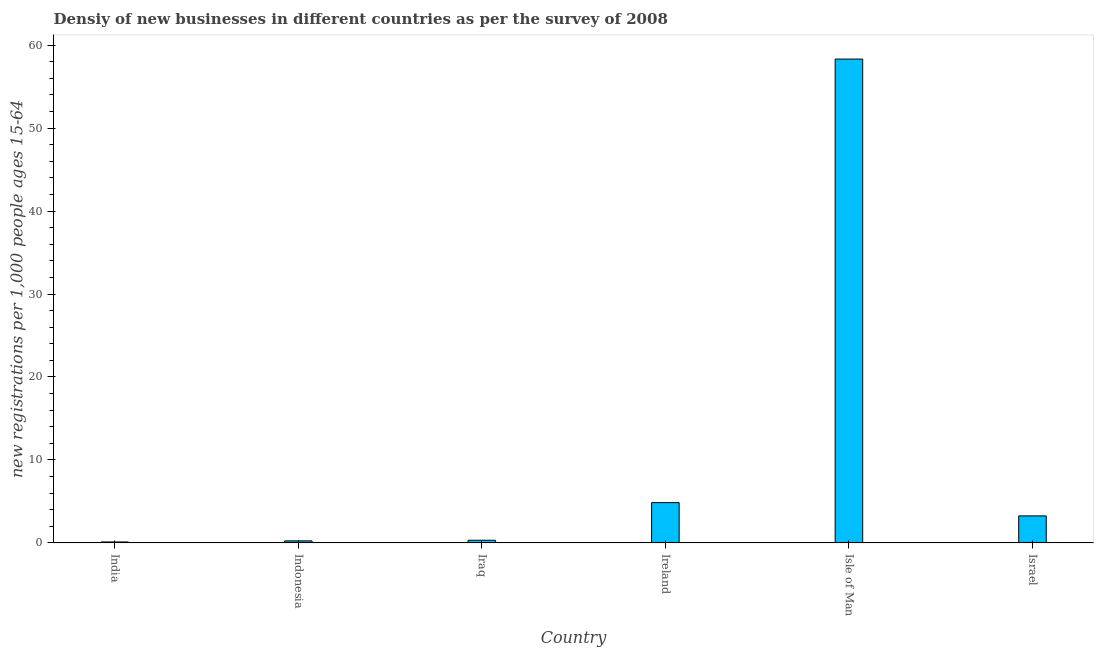Does the graph contain any zero values?
Offer a terse response. No. What is the title of the graph?
Give a very brief answer. Densiy of new businesses in different countries as per the survey of 2008. What is the label or title of the Y-axis?
Ensure brevity in your answer.  New registrations per 1,0 people ages 15-64. What is the density of new business in India?
Give a very brief answer. 0.11. Across all countries, what is the maximum density of new business?
Your answer should be very brief. 58.33. Across all countries, what is the minimum density of new business?
Your answer should be very brief. 0.11. In which country was the density of new business maximum?
Your response must be concise. Isle of Man. In which country was the density of new business minimum?
Provide a succinct answer. India. What is the sum of the density of new business?
Ensure brevity in your answer.  67.11. What is the difference between the density of new business in Indonesia and Isle of Man?
Your answer should be compact. -58.09. What is the average density of new business per country?
Keep it short and to the point. 11.19. What is the median density of new business?
Your answer should be very brief. 1.79. In how many countries, is the density of new business greater than 24 ?
Keep it short and to the point. 1. What is the difference between the highest and the second highest density of new business?
Keep it short and to the point. 53.48. What is the difference between the highest and the lowest density of new business?
Offer a terse response. 58.22. In how many countries, is the density of new business greater than the average density of new business taken over all countries?
Ensure brevity in your answer.  1. How many countries are there in the graph?
Your answer should be compact. 6. What is the difference between two consecutive major ticks on the Y-axis?
Offer a terse response. 10. Are the values on the major ticks of Y-axis written in scientific E-notation?
Give a very brief answer. No. What is the new registrations per 1,000 people ages 15-64 of India?
Offer a terse response. 0.11. What is the new registrations per 1,000 people ages 15-64 of Indonesia?
Your answer should be compact. 0.24. What is the new registrations per 1,000 people ages 15-64 in Iraq?
Offer a very short reply. 0.32. What is the new registrations per 1,000 people ages 15-64 in Ireland?
Provide a succinct answer. 4.85. What is the new registrations per 1,000 people ages 15-64 in Isle of Man?
Ensure brevity in your answer.  58.33. What is the new registrations per 1,000 people ages 15-64 in Israel?
Provide a succinct answer. 3.25. What is the difference between the new registrations per 1,000 people ages 15-64 in India and Indonesia?
Provide a short and direct response. -0.13. What is the difference between the new registrations per 1,000 people ages 15-64 in India and Iraq?
Offer a terse response. -0.2. What is the difference between the new registrations per 1,000 people ages 15-64 in India and Ireland?
Make the answer very short. -4.74. What is the difference between the new registrations per 1,000 people ages 15-64 in India and Isle of Man?
Offer a terse response. -58.22. What is the difference between the new registrations per 1,000 people ages 15-64 in India and Israel?
Give a very brief answer. -3.14. What is the difference between the new registrations per 1,000 people ages 15-64 in Indonesia and Iraq?
Offer a very short reply. -0.07. What is the difference between the new registrations per 1,000 people ages 15-64 in Indonesia and Ireland?
Offer a terse response. -4.61. What is the difference between the new registrations per 1,000 people ages 15-64 in Indonesia and Isle of Man?
Your answer should be compact. -58.09. What is the difference between the new registrations per 1,000 people ages 15-64 in Indonesia and Israel?
Your answer should be very brief. -3.01. What is the difference between the new registrations per 1,000 people ages 15-64 in Iraq and Ireland?
Offer a very short reply. -4.54. What is the difference between the new registrations per 1,000 people ages 15-64 in Iraq and Isle of Man?
Give a very brief answer. -58.01. What is the difference between the new registrations per 1,000 people ages 15-64 in Iraq and Israel?
Your response must be concise. -2.94. What is the difference between the new registrations per 1,000 people ages 15-64 in Ireland and Isle of Man?
Give a very brief answer. -53.48. What is the difference between the new registrations per 1,000 people ages 15-64 in Ireland and Israel?
Provide a short and direct response. 1.6. What is the difference between the new registrations per 1,000 people ages 15-64 in Isle of Man and Israel?
Your answer should be compact. 55.08. What is the ratio of the new registrations per 1,000 people ages 15-64 in India to that in Indonesia?
Your answer should be compact. 0.46. What is the ratio of the new registrations per 1,000 people ages 15-64 in India to that in Iraq?
Your response must be concise. 0.35. What is the ratio of the new registrations per 1,000 people ages 15-64 in India to that in Ireland?
Give a very brief answer. 0.02. What is the ratio of the new registrations per 1,000 people ages 15-64 in India to that in Isle of Man?
Give a very brief answer. 0. What is the ratio of the new registrations per 1,000 people ages 15-64 in India to that in Israel?
Your response must be concise. 0.04. What is the ratio of the new registrations per 1,000 people ages 15-64 in Indonesia to that in Iraq?
Ensure brevity in your answer.  0.77. What is the ratio of the new registrations per 1,000 people ages 15-64 in Indonesia to that in Isle of Man?
Provide a short and direct response. 0. What is the ratio of the new registrations per 1,000 people ages 15-64 in Indonesia to that in Israel?
Keep it short and to the point. 0.07. What is the ratio of the new registrations per 1,000 people ages 15-64 in Iraq to that in Ireland?
Keep it short and to the point. 0.07. What is the ratio of the new registrations per 1,000 people ages 15-64 in Iraq to that in Isle of Man?
Offer a very short reply. 0.01. What is the ratio of the new registrations per 1,000 people ages 15-64 in Iraq to that in Israel?
Ensure brevity in your answer.  0.1. What is the ratio of the new registrations per 1,000 people ages 15-64 in Ireland to that in Isle of Man?
Offer a terse response. 0.08. What is the ratio of the new registrations per 1,000 people ages 15-64 in Ireland to that in Israel?
Ensure brevity in your answer.  1.49. What is the ratio of the new registrations per 1,000 people ages 15-64 in Isle of Man to that in Israel?
Keep it short and to the point. 17.93. 